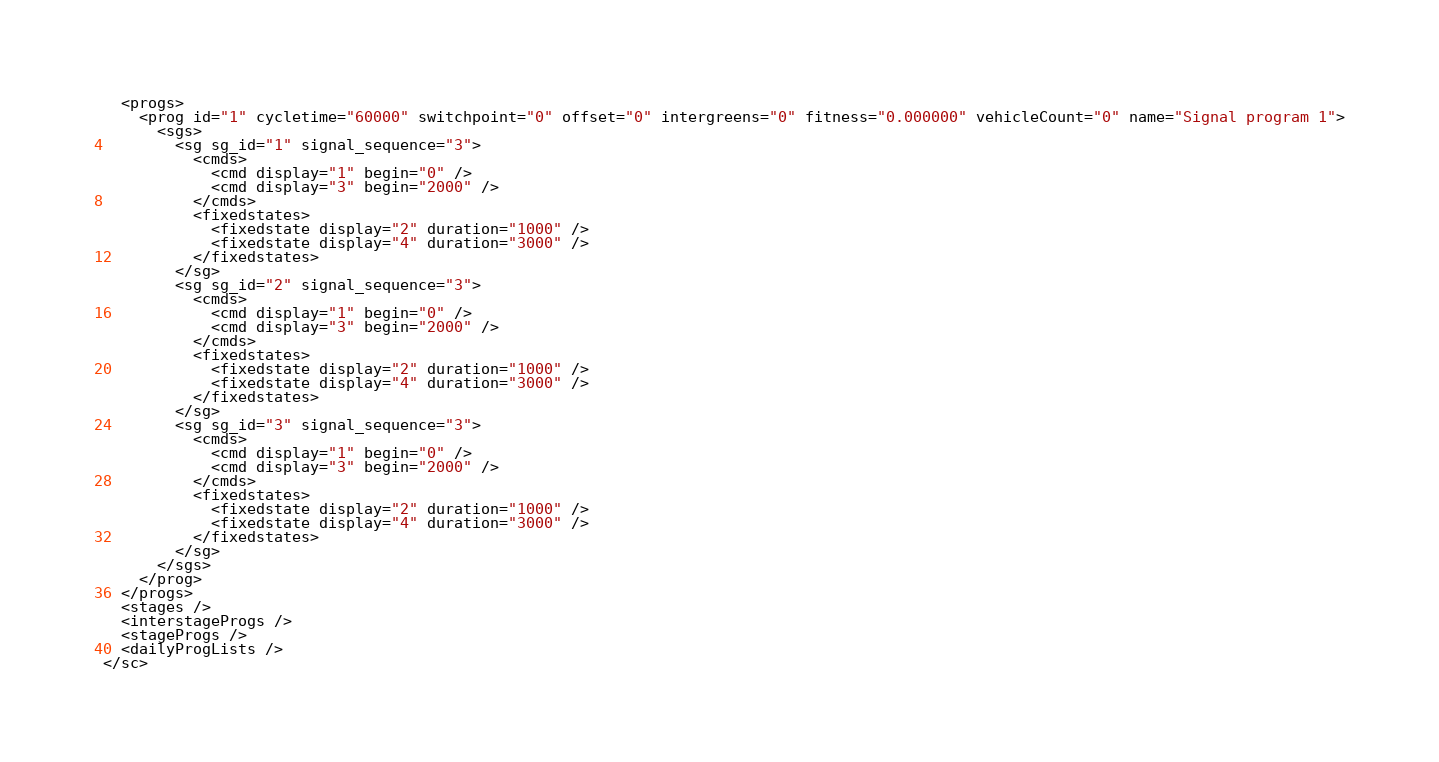Convert code to text. <code><loc_0><loc_0><loc_500><loc_500><_SML_>  <progs>
    <prog id="1" cycletime="60000" switchpoint="0" offset="0" intergreens="0" fitness="0.000000" vehicleCount="0" name="Signal program 1">
      <sgs>
        <sg sg_id="1" signal_sequence="3">
          <cmds>
            <cmd display="1" begin="0" />
            <cmd display="3" begin="2000" />
          </cmds>
          <fixedstates>
            <fixedstate display="2" duration="1000" />
            <fixedstate display="4" duration="3000" />
          </fixedstates>
        </sg>
        <sg sg_id="2" signal_sequence="3">
          <cmds>
            <cmd display="1" begin="0" />
            <cmd display="3" begin="2000" />
          </cmds>
          <fixedstates>
            <fixedstate display="2" duration="1000" />
            <fixedstate display="4" duration="3000" />
          </fixedstates>
        </sg>
        <sg sg_id="3" signal_sequence="3">
          <cmds>
            <cmd display="1" begin="0" />
            <cmd display="3" begin="2000" />
          </cmds>
          <fixedstates>
            <fixedstate display="2" duration="1000" />
            <fixedstate display="4" duration="3000" />
          </fixedstates>
        </sg>
      </sgs>
    </prog>
  </progs>
  <stages />
  <interstageProgs />
  <stageProgs />
  <dailyProgLists />
</sc></code> 